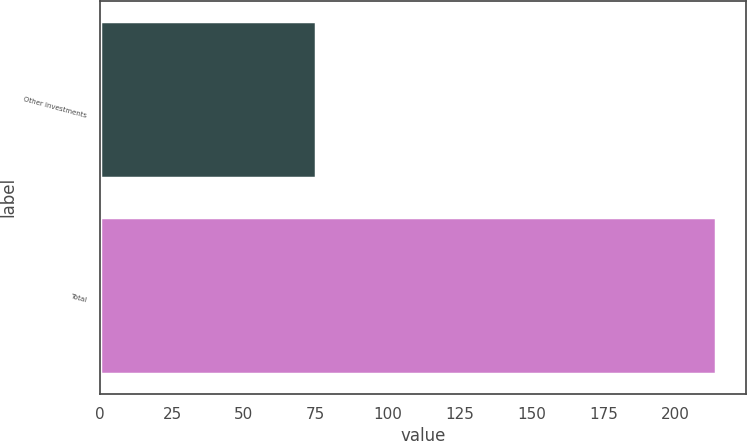Convert chart to OTSL. <chart><loc_0><loc_0><loc_500><loc_500><bar_chart><fcel>Other investments<fcel>Total<nl><fcel>75<fcel>214<nl></chart> 